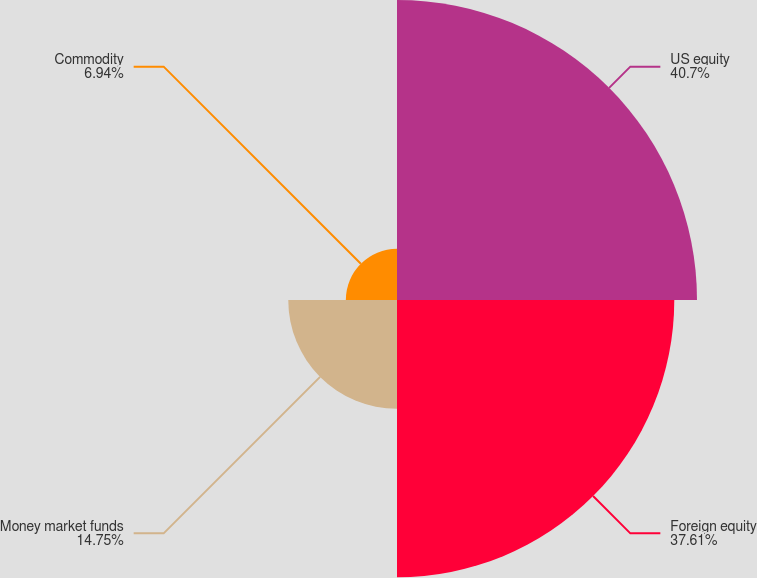<chart> <loc_0><loc_0><loc_500><loc_500><pie_chart><fcel>US equity<fcel>Foreign equity<fcel>Money market funds<fcel>Commodity<nl><fcel>40.69%<fcel>37.61%<fcel>14.75%<fcel>6.94%<nl></chart> 